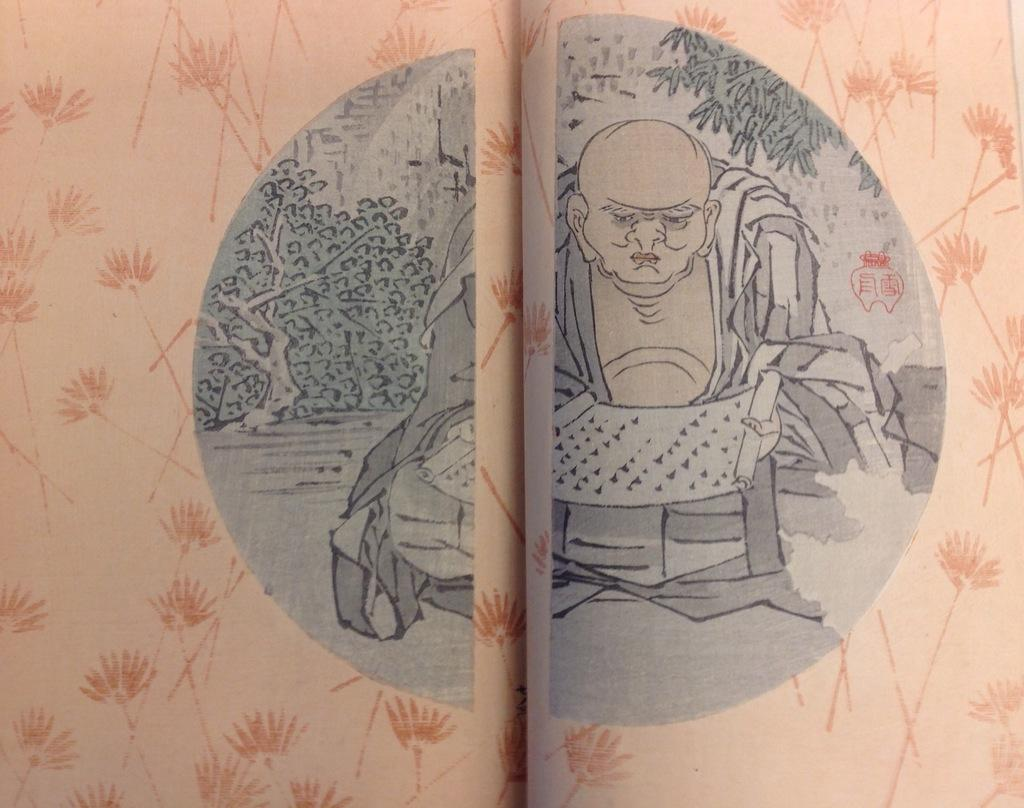What type of image is present in the picture? There is an animated image of a person in the image. What can be seen in the background or on objects in the image? There are trees on objects in the image. What type of bag is being used by the team in the image? There is no team or bag present in the image; it features an animated person and trees on objects. 